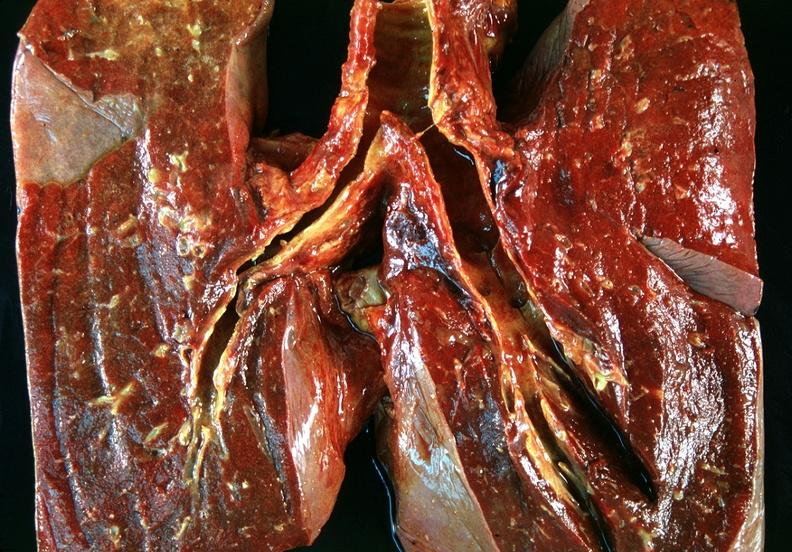what is present?
Answer the question using a single word or phrase. Respiratory 